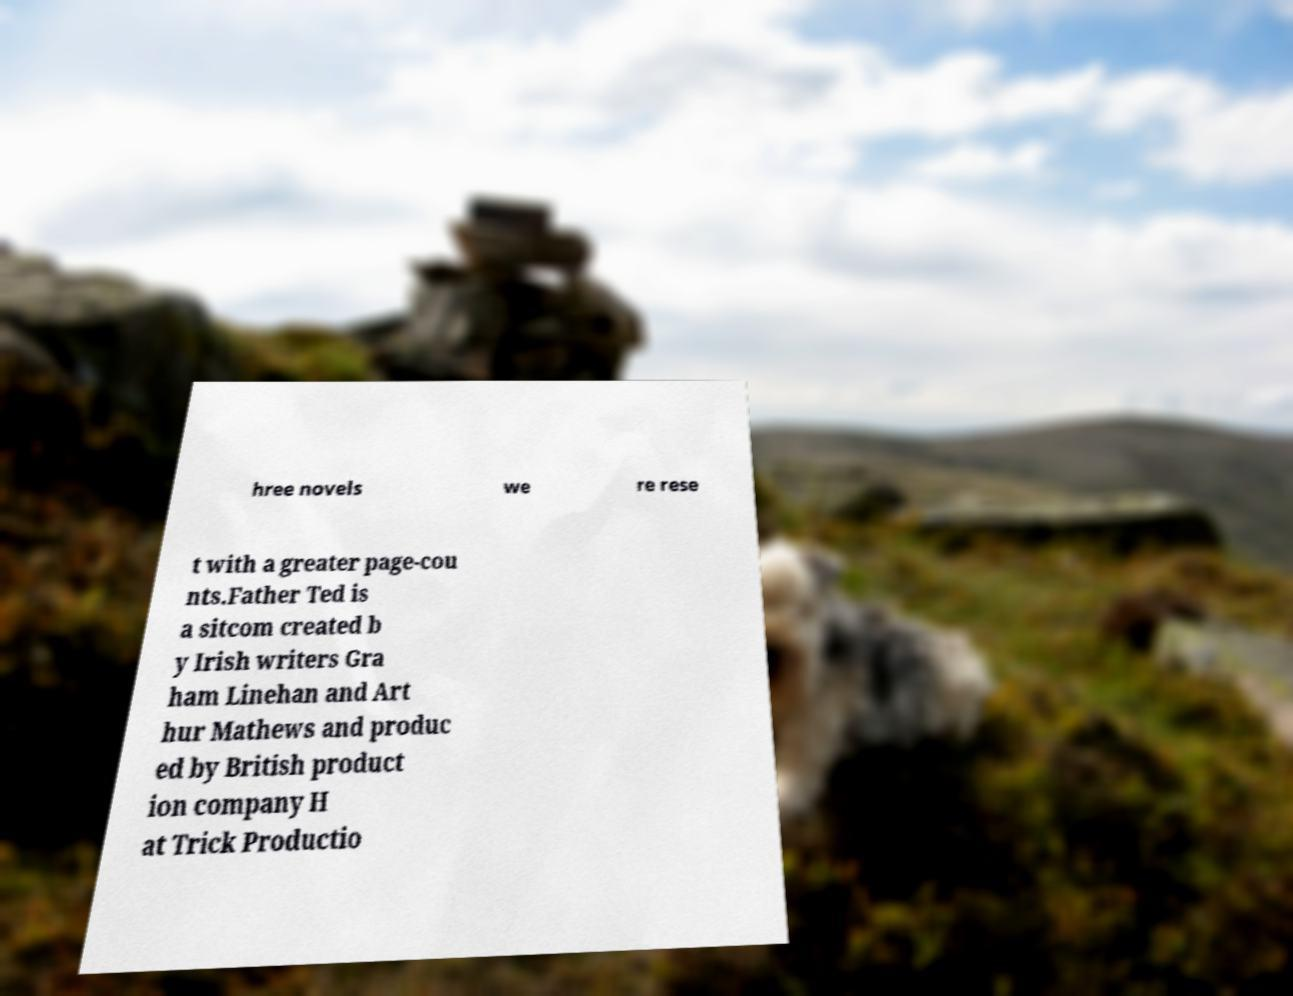Could you assist in decoding the text presented in this image and type it out clearly? hree novels we re rese t with a greater page-cou nts.Father Ted is a sitcom created b y Irish writers Gra ham Linehan and Art hur Mathews and produc ed by British product ion company H at Trick Productio 